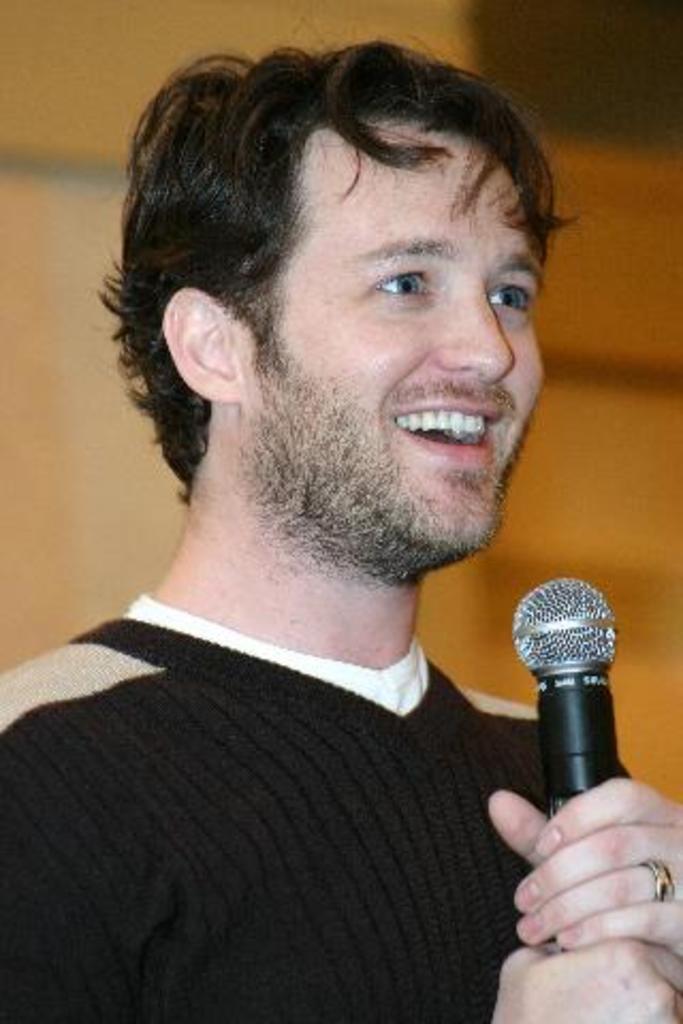Can you describe this image briefly? In this image we can see this person wearing black T-shirt is holding mic in his hands and smiling. The background of the image is slightly blurred. 